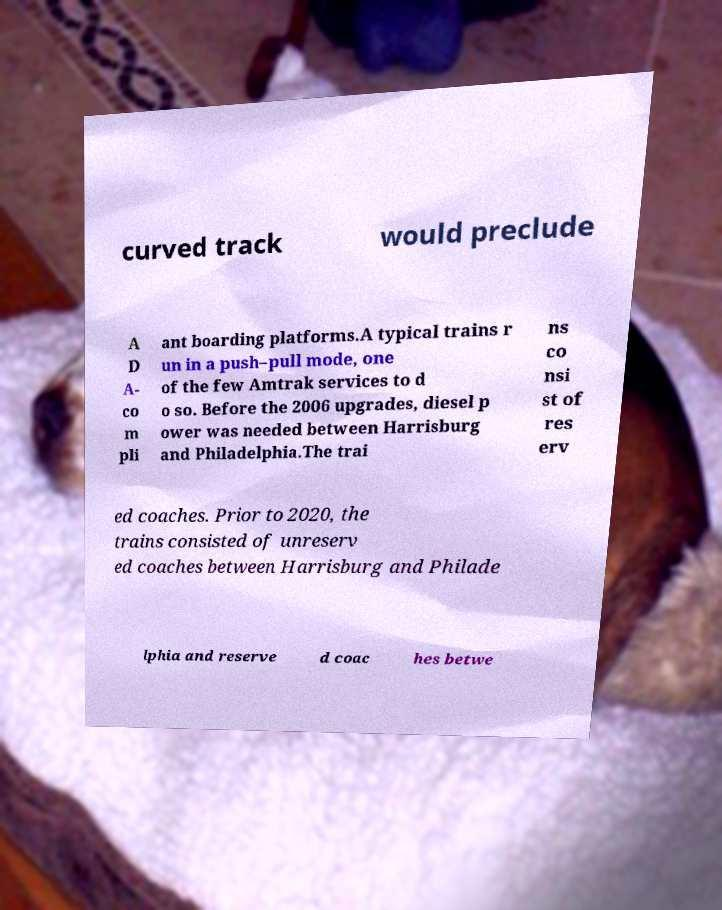Can you read and provide the text displayed in the image?This photo seems to have some interesting text. Can you extract and type it out for me? curved track would preclude A D A- co m pli ant boarding platforms.A typical trains r un in a push–pull mode, one of the few Amtrak services to d o so. Before the 2006 upgrades, diesel p ower was needed between Harrisburg and Philadelphia.The trai ns co nsi st of res erv ed coaches. Prior to 2020, the trains consisted of unreserv ed coaches between Harrisburg and Philade lphia and reserve d coac hes betwe 